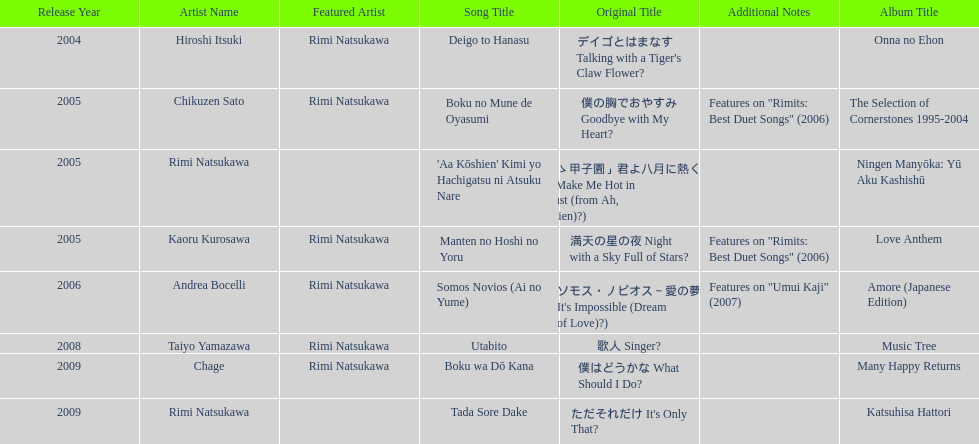Which was released earlier, deigo to hanasu or utabito? Deigo to Hanasu. 